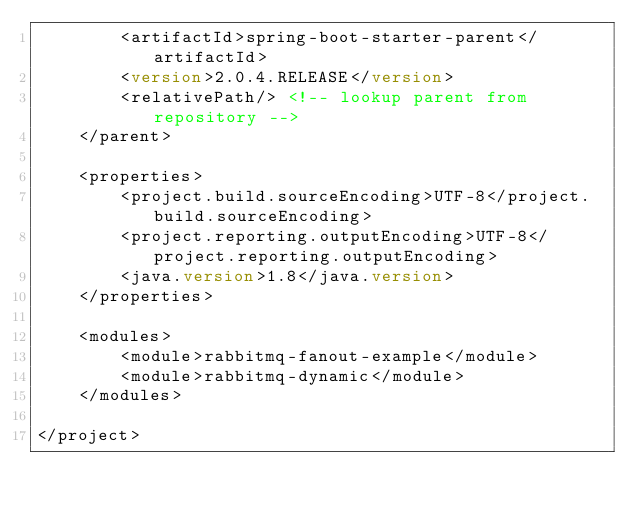<code> <loc_0><loc_0><loc_500><loc_500><_XML_>        <artifactId>spring-boot-starter-parent</artifactId>
        <version>2.0.4.RELEASE</version>
        <relativePath/> <!-- lookup parent from repository -->
    </parent>

    <properties>
        <project.build.sourceEncoding>UTF-8</project.build.sourceEncoding>
        <project.reporting.outputEncoding>UTF-8</project.reporting.outputEncoding>
        <java.version>1.8</java.version>
    </properties>

    <modules>
        <module>rabbitmq-fanout-example</module>
        <module>rabbitmq-dynamic</module>
    </modules>

</project>
</code> 